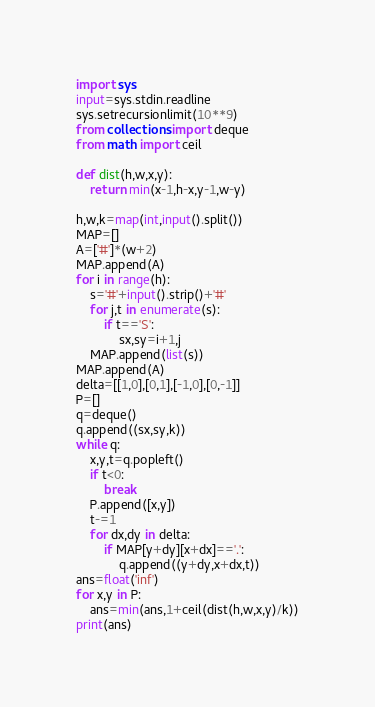Convert code to text. <code><loc_0><loc_0><loc_500><loc_500><_Python_>import sys
input=sys.stdin.readline
sys.setrecursionlimit(10**9)
from collections import deque
from math import ceil

def dist(h,w,x,y):
    return min(x-1,h-x,y-1,w-y)

h,w,k=map(int,input().split())
MAP=[]
A=['#']*(w+2)
MAP.append(A)
for i in range(h):
    s='#'+input().strip()+'#'
    for j,t in enumerate(s):
        if t=='S':
            sx,sy=i+1,j
    MAP.append(list(s))
MAP.append(A)
delta=[[1,0],[0,1],[-1,0],[0,-1]]
P=[]
q=deque()
q.append((sx,sy,k))
while q:
    x,y,t=q.popleft()
    if t<0:
        break
    P.append([x,y])
    t-=1
    for dx,dy in delta:
        if MAP[y+dy][x+dx]=='.':
            q.append((y+dy,x+dx,t))
ans=float('inf')
for x,y in P:
    ans=min(ans,1+ceil(dist(h,w,x,y)/k))
print(ans)</code> 